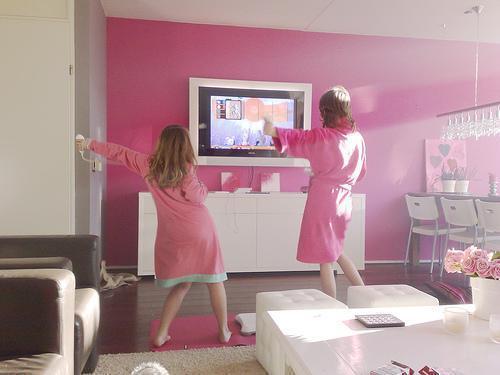What is featured by the TV?
Answer the question by selecting the correct answer among the 4 following choices.
Options: Dolls, dancing show, video game, workout. Video game. 